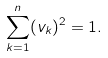Convert formula to latex. <formula><loc_0><loc_0><loc_500><loc_500>\sum _ { k = 1 } ^ { n } ( v _ { k } ) ^ { 2 } = 1 .</formula> 